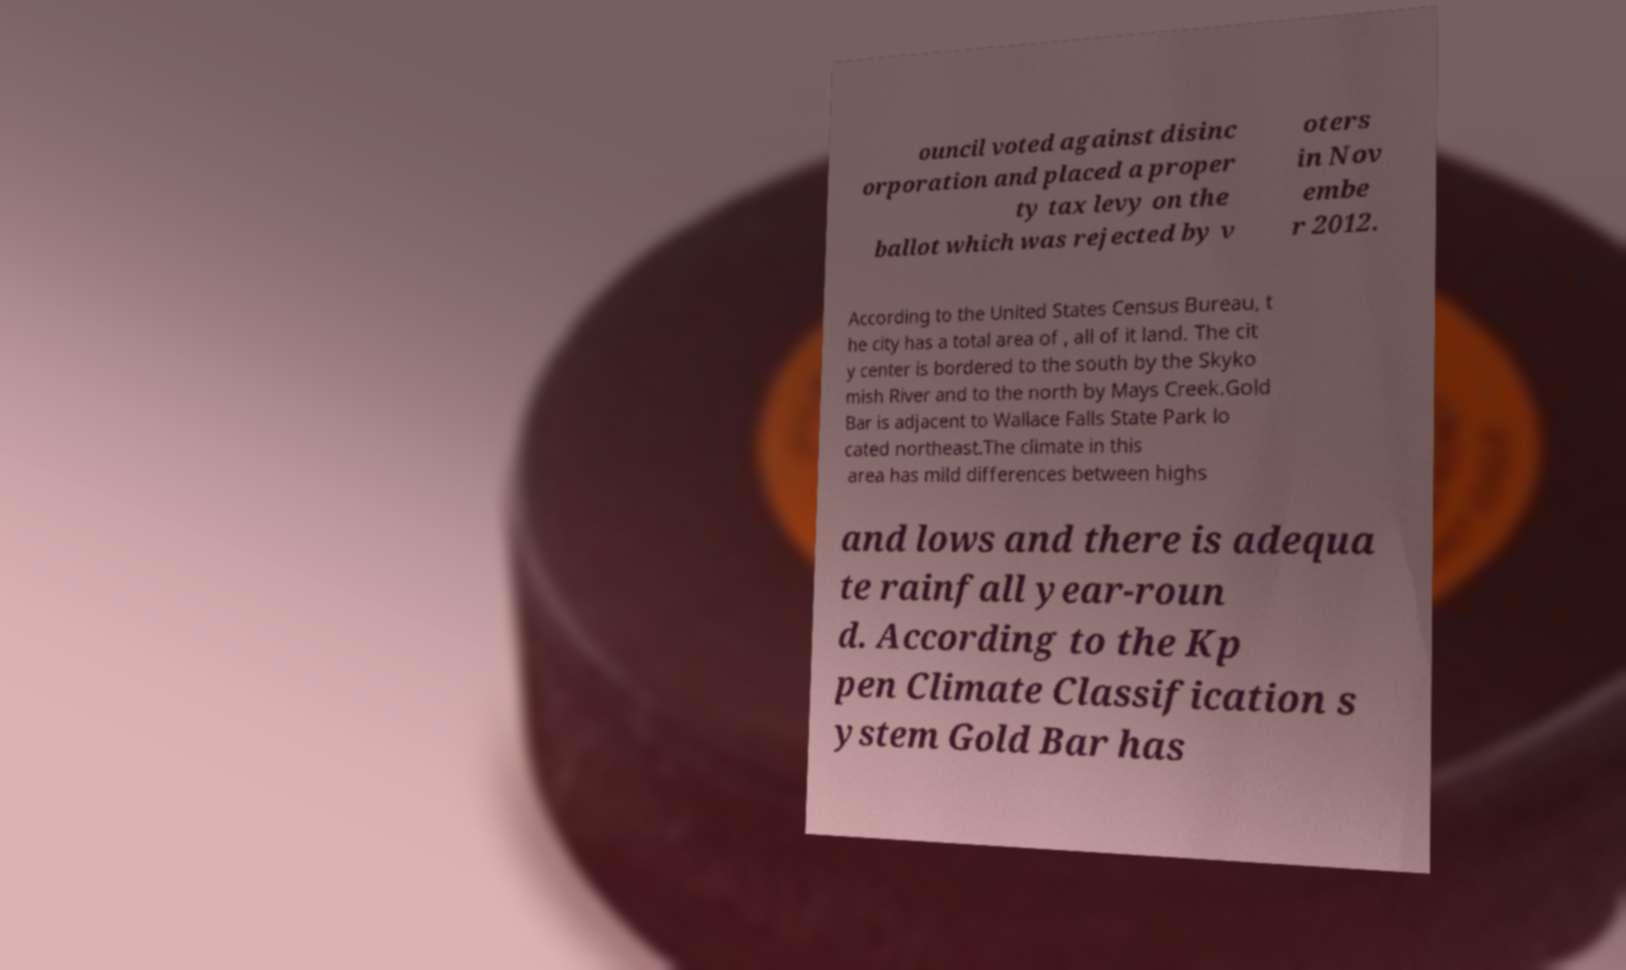Could you extract and type out the text from this image? ouncil voted against disinc orporation and placed a proper ty tax levy on the ballot which was rejected by v oters in Nov embe r 2012. According to the United States Census Bureau, t he city has a total area of , all of it land. The cit y center is bordered to the south by the Skyko mish River and to the north by Mays Creek.Gold Bar is adjacent to Wallace Falls State Park lo cated northeast.The climate in this area has mild differences between highs and lows and there is adequa te rainfall year-roun d. According to the Kp pen Climate Classification s ystem Gold Bar has 